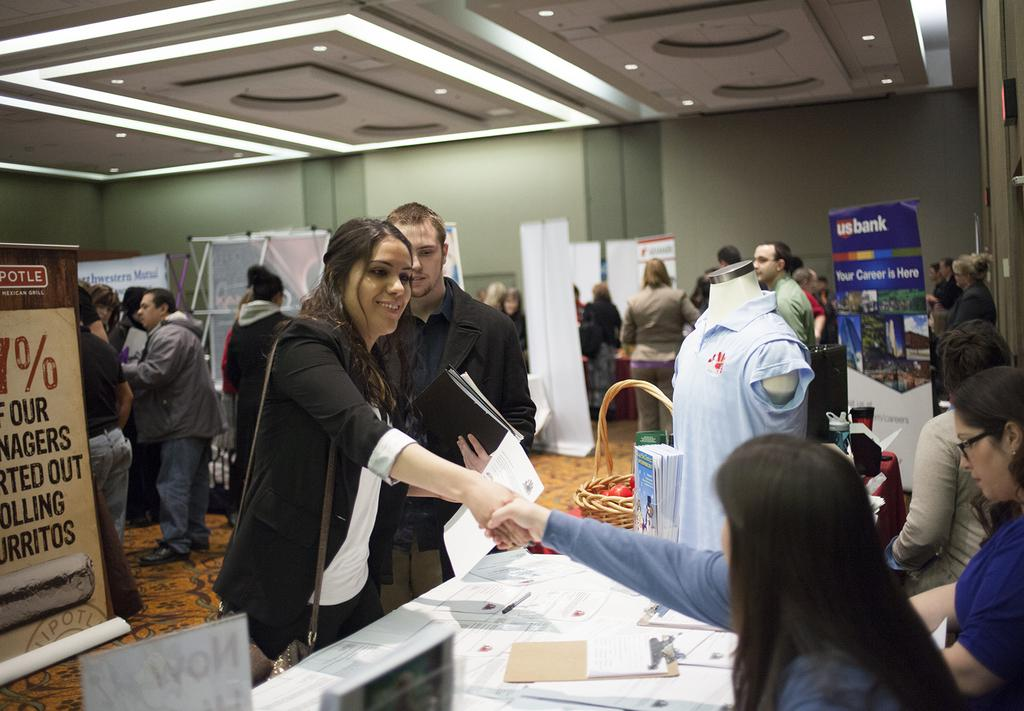<image>
Offer a succinct explanation of the picture presented. Two women shaking hands at a stand that says USbank. 